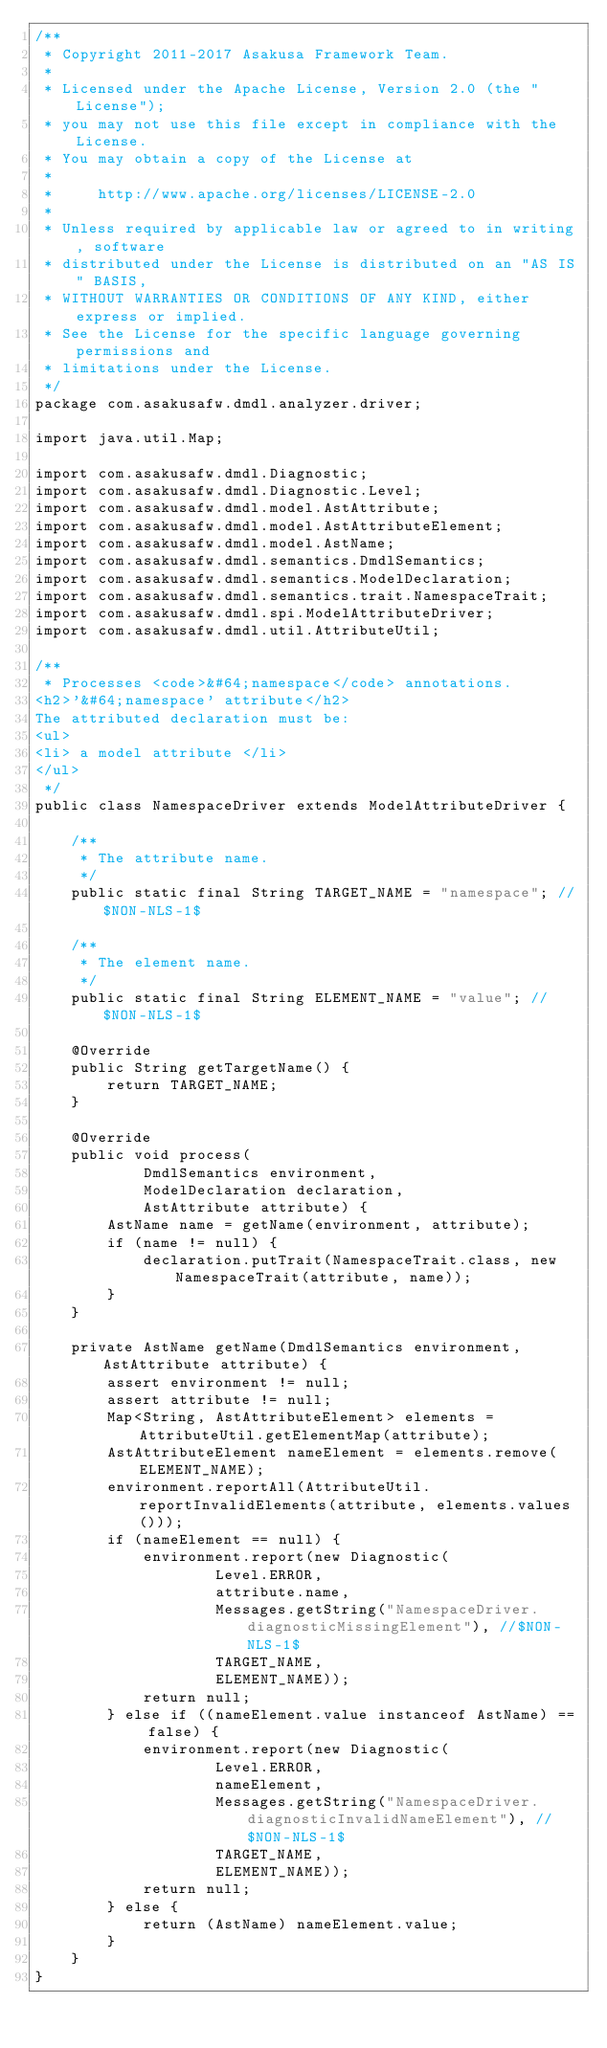<code> <loc_0><loc_0><loc_500><loc_500><_Java_>/**
 * Copyright 2011-2017 Asakusa Framework Team.
 *
 * Licensed under the Apache License, Version 2.0 (the "License");
 * you may not use this file except in compliance with the License.
 * You may obtain a copy of the License at
 *
 *     http://www.apache.org/licenses/LICENSE-2.0
 *
 * Unless required by applicable law or agreed to in writing, software
 * distributed under the License is distributed on an "AS IS" BASIS,
 * WITHOUT WARRANTIES OR CONDITIONS OF ANY KIND, either express or implied.
 * See the License for the specific language governing permissions and
 * limitations under the License.
 */
package com.asakusafw.dmdl.analyzer.driver;

import java.util.Map;

import com.asakusafw.dmdl.Diagnostic;
import com.asakusafw.dmdl.Diagnostic.Level;
import com.asakusafw.dmdl.model.AstAttribute;
import com.asakusafw.dmdl.model.AstAttributeElement;
import com.asakusafw.dmdl.model.AstName;
import com.asakusafw.dmdl.semantics.DmdlSemantics;
import com.asakusafw.dmdl.semantics.ModelDeclaration;
import com.asakusafw.dmdl.semantics.trait.NamespaceTrait;
import com.asakusafw.dmdl.spi.ModelAttributeDriver;
import com.asakusafw.dmdl.util.AttributeUtil;

/**
 * Processes <code>&#64;namespace</code> annotations.
<h2>'&#64;namespace' attribute</h2>
The attributed declaration must be:
<ul>
<li> a model attribute </li>
</ul>
 */
public class NamespaceDriver extends ModelAttributeDriver {

    /**
     * The attribute name.
     */
    public static final String TARGET_NAME = "namespace"; //$NON-NLS-1$

    /**
     * The element name.
     */
    public static final String ELEMENT_NAME = "value"; //$NON-NLS-1$

    @Override
    public String getTargetName() {
        return TARGET_NAME;
    }

    @Override
    public void process(
            DmdlSemantics environment,
            ModelDeclaration declaration,
            AstAttribute attribute) {
        AstName name = getName(environment, attribute);
        if (name != null) {
            declaration.putTrait(NamespaceTrait.class, new NamespaceTrait(attribute, name));
        }
    }

    private AstName getName(DmdlSemantics environment, AstAttribute attribute) {
        assert environment != null;
        assert attribute != null;
        Map<String, AstAttributeElement> elements = AttributeUtil.getElementMap(attribute);
        AstAttributeElement nameElement = elements.remove(ELEMENT_NAME);
        environment.reportAll(AttributeUtil.reportInvalidElements(attribute, elements.values()));
        if (nameElement == null) {
            environment.report(new Diagnostic(
                    Level.ERROR,
                    attribute.name,
                    Messages.getString("NamespaceDriver.diagnosticMissingElement"), //$NON-NLS-1$
                    TARGET_NAME,
                    ELEMENT_NAME));
            return null;
        } else if ((nameElement.value instanceof AstName) == false) {
            environment.report(new Diagnostic(
                    Level.ERROR,
                    nameElement,
                    Messages.getString("NamespaceDriver.diagnosticInvalidNameElement"), //$NON-NLS-1$
                    TARGET_NAME,
                    ELEMENT_NAME));
            return null;
        } else {
            return (AstName) nameElement.value;
        }
    }
}
</code> 